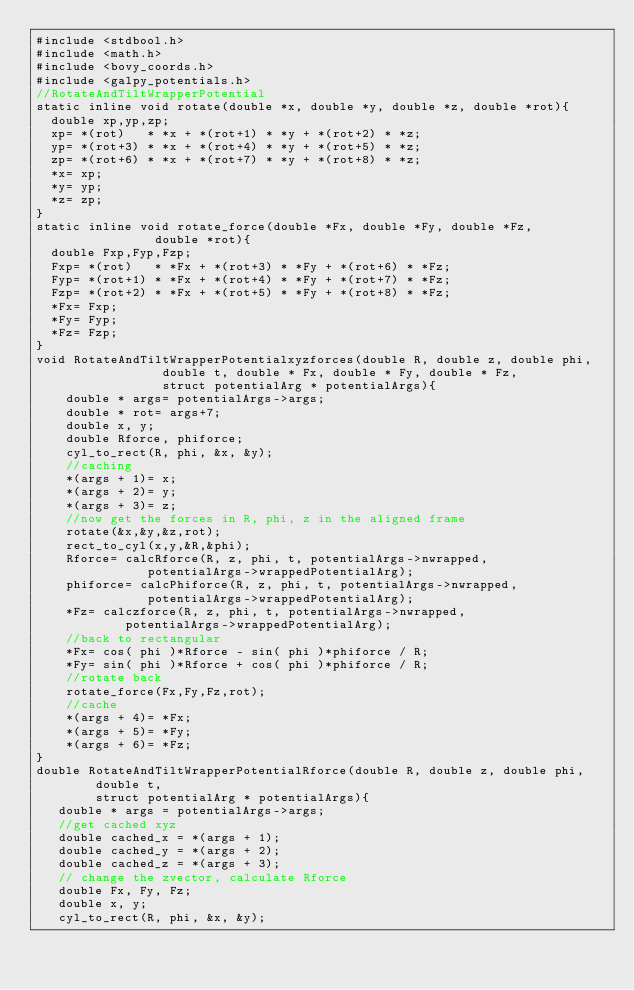Convert code to text. <code><loc_0><loc_0><loc_500><loc_500><_C_>#include <stdbool.h>
#include <math.h>
#include <bovy_coords.h>
#include <galpy_potentials.h>
//RotateAndTiltWrapperPotential
static inline void rotate(double *x, double *y, double *z, double *rot){
  double xp,yp,zp;
  xp= *(rot)   * *x + *(rot+1) * *y + *(rot+2) * *z;
  yp= *(rot+3) * *x + *(rot+4) * *y + *(rot+5) * *z;
  zp= *(rot+6) * *x + *(rot+7) * *y + *(rot+8) * *z;
  *x= xp;
  *y= yp;
  *z= zp;
}
static inline void rotate_force(double *Fx, double *Fy, double *Fz,
				double *rot){
  double Fxp,Fyp,Fzp;
  Fxp= *(rot)   * *Fx + *(rot+3) * *Fy + *(rot+6) * *Fz;
  Fyp= *(rot+1) * *Fx + *(rot+4) * *Fy + *(rot+7) * *Fz;
  Fzp= *(rot+2) * *Fx + *(rot+5) * *Fy + *(rot+8) * *Fz;
  *Fx= Fxp;
  *Fy= Fyp;
  *Fz= Fzp;
}
void RotateAndTiltWrapperPotentialxyzforces(double R, double z, double phi,
                 double t, double * Fx, double * Fy, double * Fz,
                 struct potentialArg * potentialArgs){
    double * args= potentialArgs->args;
    double * rot= args+7;
    double x, y;
    double Rforce, phiforce;
    cyl_to_rect(R, phi, &x, &y);
    //caching
    *(args + 1)= x;
    *(args + 2)= y;
    *(args + 3)= z;
    //now get the forces in R, phi, z in the aligned frame
    rotate(&x,&y,&z,rot);
    rect_to_cyl(x,y,&R,&phi);
    Rforce= calcRforce(R, z, phi, t, potentialArgs->nwrapped,
		       potentialArgs->wrappedPotentialArg);
    phiforce= calcPhiforce(R, z, phi, t, potentialArgs->nwrapped,
			   potentialArgs->wrappedPotentialArg);
    *Fz= calczforce(R, z, phi, t, potentialArgs->nwrapped,
		    potentialArgs->wrappedPotentialArg);
    //back to rectangular
    *Fx= cos( phi )*Rforce - sin( phi )*phiforce / R;
    *Fy= sin( phi )*Rforce + cos( phi )*phiforce / R;
    //rotate back
    rotate_force(Fx,Fy,Fz,rot);
    //cache
    *(args + 4)= *Fx;
    *(args + 5)= *Fy;
    *(args + 6)= *Fz;
}
double RotateAndTiltWrapperPotentialRforce(double R, double z, double phi,
        double t,
        struct potentialArg * potentialArgs){
   double * args = potentialArgs->args;
   //get cached xyz
   double cached_x = *(args + 1);
   double cached_y = *(args + 2);
   double cached_z = *(args + 3);
   // change the zvector, calculate Rforce
   double Fx, Fy, Fz;
   double x, y;
   cyl_to_rect(R, phi, &x, &y);</code> 